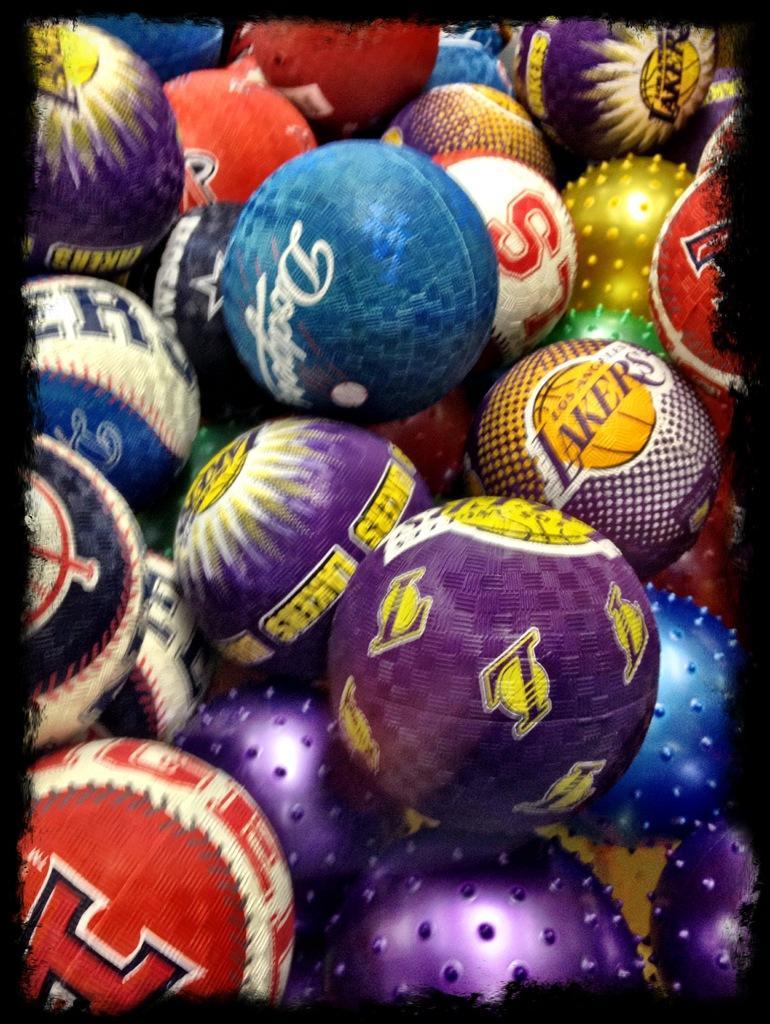How would you summarize this image in a sentence or two? Here in this picture we can see different colored balls present over there. 